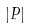<formula> <loc_0><loc_0><loc_500><loc_500>\left | P \right |</formula> 